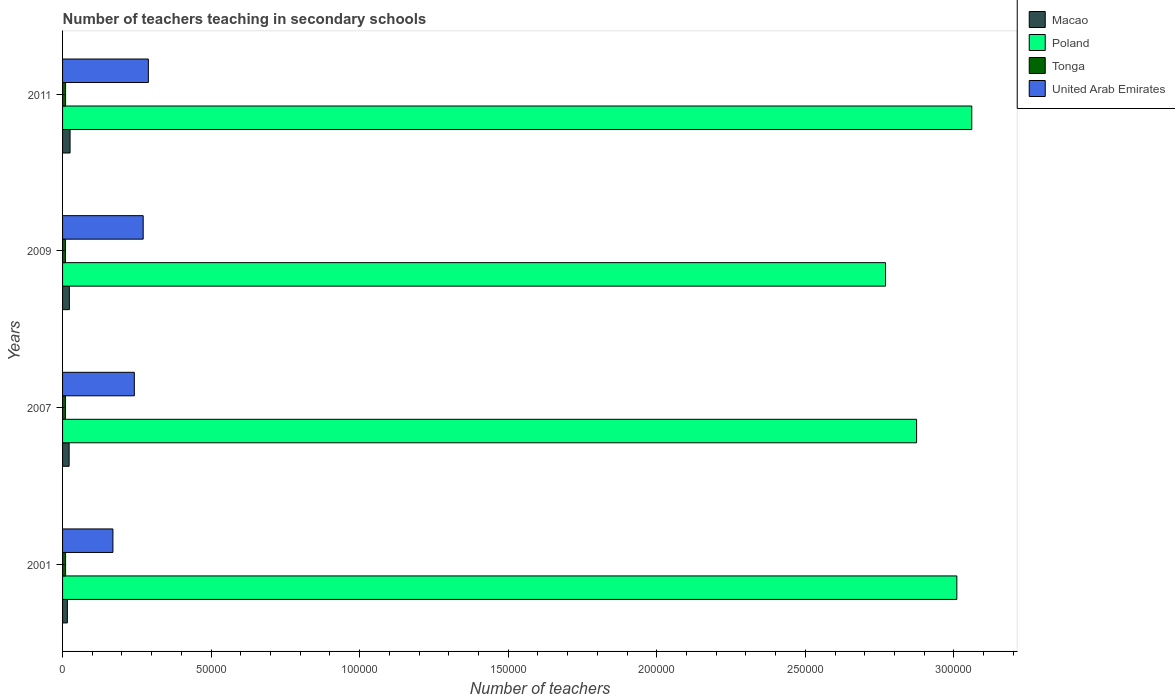How many different coloured bars are there?
Provide a short and direct response. 4. How many groups of bars are there?
Offer a terse response. 4. Are the number of bars per tick equal to the number of legend labels?
Your answer should be compact. Yes. How many bars are there on the 2nd tick from the bottom?
Your answer should be very brief. 4. What is the number of teachers teaching in secondary schools in Poland in 2001?
Offer a terse response. 3.01e+05. Across all years, what is the maximum number of teachers teaching in secondary schools in United Arab Emirates?
Your answer should be very brief. 2.89e+04. Across all years, what is the minimum number of teachers teaching in secondary schools in Macao?
Make the answer very short. 1621. In which year was the number of teachers teaching in secondary schools in United Arab Emirates minimum?
Offer a terse response. 2001. What is the total number of teachers teaching in secondary schools in United Arab Emirates in the graph?
Ensure brevity in your answer.  9.71e+04. What is the difference between the number of teachers teaching in secondary schools in Poland in 2009 and that in 2011?
Offer a terse response. -2.90e+04. What is the difference between the number of teachers teaching in secondary schools in Tonga in 2007 and the number of teachers teaching in secondary schools in Poland in 2001?
Ensure brevity in your answer.  -3.00e+05. What is the average number of teachers teaching in secondary schools in Macao per year?
Your answer should be compact. 2162. In the year 2001, what is the difference between the number of teachers teaching in secondary schools in Macao and number of teachers teaching in secondary schools in Poland?
Provide a succinct answer. -2.99e+05. What is the ratio of the number of teachers teaching in secondary schools in Tonga in 2001 to that in 2009?
Offer a terse response. 1.04. What is the difference between the highest and the second highest number of teachers teaching in secondary schools in Tonga?
Ensure brevity in your answer.  0. What is the difference between the highest and the lowest number of teachers teaching in secondary schools in Poland?
Offer a very short reply. 2.90e+04. Is the sum of the number of teachers teaching in secondary schools in Macao in 2001 and 2009 greater than the maximum number of teachers teaching in secondary schools in Tonga across all years?
Your answer should be compact. Yes. What does the 4th bar from the top in 2009 represents?
Your answer should be compact. Macao. What does the 3rd bar from the bottom in 2011 represents?
Provide a succinct answer. Tonga. Are all the bars in the graph horizontal?
Offer a terse response. Yes. How many years are there in the graph?
Your response must be concise. 4. What is the difference between two consecutive major ticks on the X-axis?
Offer a terse response. 5.00e+04. Are the values on the major ticks of X-axis written in scientific E-notation?
Make the answer very short. No. What is the title of the graph?
Offer a very short reply. Number of teachers teaching in secondary schools. What is the label or title of the X-axis?
Offer a terse response. Number of teachers. What is the Number of teachers of Macao in 2001?
Offer a terse response. 1621. What is the Number of teachers of Poland in 2001?
Ensure brevity in your answer.  3.01e+05. What is the Number of teachers of Tonga in 2001?
Offer a terse response. 1021. What is the Number of teachers of United Arab Emirates in 2001?
Your answer should be very brief. 1.70e+04. What is the Number of teachers in Macao in 2007?
Offer a very short reply. 2210. What is the Number of teachers of Poland in 2007?
Give a very brief answer. 2.87e+05. What is the Number of teachers in Tonga in 2007?
Make the answer very short. 982. What is the Number of teachers of United Arab Emirates in 2007?
Provide a short and direct response. 2.42e+04. What is the Number of teachers in Macao in 2009?
Give a very brief answer. 2294. What is the Number of teachers in Poland in 2009?
Offer a terse response. 2.77e+05. What is the Number of teachers of Tonga in 2009?
Your response must be concise. 981. What is the Number of teachers in United Arab Emirates in 2009?
Provide a succinct answer. 2.71e+04. What is the Number of teachers in Macao in 2011?
Offer a very short reply. 2523. What is the Number of teachers of Poland in 2011?
Keep it short and to the point. 3.06e+05. What is the Number of teachers in Tonga in 2011?
Offer a very short reply. 1021. What is the Number of teachers of United Arab Emirates in 2011?
Your response must be concise. 2.89e+04. Across all years, what is the maximum Number of teachers in Macao?
Your answer should be very brief. 2523. Across all years, what is the maximum Number of teachers in Poland?
Your response must be concise. 3.06e+05. Across all years, what is the maximum Number of teachers in Tonga?
Give a very brief answer. 1021. Across all years, what is the maximum Number of teachers in United Arab Emirates?
Provide a succinct answer. 2.89e+04. Across all years, what is the minimum Number of teachers of Macao?
Offer a very short reply. 1621. Across all years, what is the minimum Number of teachers of Poland?
Keep it short and to the point. 2.77e+05. Across all years, what is the minimum Number of teachers in Tonga?
Ensure brevity in your answer.  981. Across all years, what is the minimum Number of teachers in United Arab Emirates?
Your answer should be very brief. 1.70e+04. What is the total Number of teachers of Macao in the graph?
Your answer should be very brief. 8648. What is the total Number of teachers in Poland in the graph?
Make the answer very short. 1.17e+06. What is the total Number of teachers of Tonga in the graph?
Your response must be concise. 4005. What is the total Number of teachers in United Arab Emirates in the graph?
Your answer should be very brief. 9.71e+04. What is the difference between the Number of teachers of Macao in 2001 and that in 2007?
Offer a very short reply. -589. What is the difference between the Number of teachers of Poland in 2001 and that in 2007?
Provide a short and direct response. 1.35e+04. What is the difference between the Number of teachers in Tonga in 2001 and that in 2007?
Ensure brevity in your answer.  39. What is the difference between the Number of teachers of United Arab Emirates in 2001 and that in 2007?
Your answer should be very brief. -7202. What is the difference between the Number of teachers of Macao in 2001 and that in 2009?
Your answer should be very brief. -673. What is the difference between the Number of teachers in Poland in 2001 and that in 2009?
Make the answer very short. 2.40e+04. What is the difference between the Number of teachers in Tonga in 2001 and that in 2009?
Make the answer very short. 40. What is the difference between the Number of teachers of United Arab Emirates in 2001 and that in 2009?
Provide a succinct answer. -1.02e+04. What is the difference between the Number of teachers in Macao in 2001 and that in 2011?
Keep it short and to the point. -902. What is the difference between the Number of teachers of Poland in 2001 and that in 2011?
Keep it short and to the point. -5020. What is the difference between the Number of teachers in Tonga in 2001 and that in 2011?
Give a very brief answer. 0. What is the difference between the Number of teachers in United Arab Emirates in 2001 and that in 2011?
Your answer should be very brief. -1.19e+04. What is the difference between the Number of teachers of Macao in 2007 and that in 2009?
Provide a succinct answer. -84. What is the difference between the Number of teachers in Poland in 2007 and that in 2009?
Your answer should be very brief. 1.05e+04. What is the difference between the Number of teachers in Tonga in 2007 and that in 2009?
Your response must be concise. 1. What is the difference between the Number of teachers in United Arab Emirates in 2007 and that in 2009?
Give a very brief answer. -2983. What is the difference between the Number of teachers of Macao in 2007 and that in 2011?
Ensure brevity in your answer.  -313. What is the difference between the Number of teachers in Poland in 2007 and that in 2011?
Your answer should be very brief. -1.86e+04. What is the difference between the Number of teachers of Tonga in 2007 and that in 2011?
Provide a succinct answer. -39. What is the difference between the Number of teachers of United Arab Emirates in 2007 and that in 2011?
Make the answer very short. -4722. What is the difference between the Number of teachers in Macao in 2009 and that in 2011?
Keep it short and to the point. -229. What is the difference between the Number of teachers in Poland in 2009 and that in 2011?
Your answer should be compact. -2.90e+04. What is the difference between the Number of teachers of United Arab Emirates in 2009 and that in 2011?
Your answer should be very brief. -1739. What is the difference between the Number of teachers in Macao in 2001 and the Number of teachers in Poland in 2007?
Make the answer very short. -2.86e+05. What is the difference between the Number of teachers in Macao in 2001 and the Number of teachers in Tonga in 2007?
Ensure brevity in your answer.  639. What is the difference between the Number of teachers in Macao in 2001 and the Number of teachers in United Arab Emirates in 2007?
Provide a short and direct response. -2.25e+04. What is the difference between the Number of teachers in Poland in 2001 and the Number of teachers in Tonga in 2007?
Give a very brief answer. 3.00e+05. What is the difference between the Number of teachers in Poland in 2001 and the Number of teachers in United Arab Emirates in 2007?
Ensure brevity in your answer.  2.77e+05. What is the difference between the Number of teachers of Tonga in 2001 and the Number of teachers of United Arab Emirates in 2007?
Your answer should be very brief. -2.31e+04. What is the difference between the Number of teachers in Macao in 2001 and the Number of teachers in Poland in 2009?
Make the answer very short. -2.75e+05. What is the difference between the Number of teachers of Macao in 2001 and the Number of teachers of Tonga in 2009?
Your response must be concise. 640. What is the difference between the Number of teachers of Macao in 2001 and the Number of teachers of United Arab Emirates in 2009?
Provide a short and direct response. -2.55e+04. What is the difference between the Number of teachers of Poland in 2001 and the Number of teachers of Tonga in 2009?
Keep it short and to the point. 3.00e+05. What is the difference between the Number of teachers of Poland in 2001 and the Number of teachers of United Arab Emirates in 2009?
Ensure brevity in your answer.  2.74e+05. What is the difference between the Number of teachers of Tonga in 2001 and the Number of teachers of United Arab Emirates in 2009?
Provide a short and direct response. -2.61e+04. What is the difference between the Number of teachers of Macao in 2001 and the Number of teachers of Poland in 2011?
Ensure brevity in your answer.  -3.04e+05. What is the difference between the Number of teachers in Macao in 2001 and the Number of teachers in Tonga in 2011?
Make the answer very short. 600. What is the difference between the Number of teachers in Macao in 2001 and the Number of teachers in United Arab Emirates in 2011?
Offer a very short reply. -2.73e+04. What is the difference between the Number of teachers in Poland in 2001 and the Number of teachers in Tonga in 2011?
Your answer should be very brief. 3.00e+05. What is the difference between the Number of teachers in Poland in 2001 and the Number of teachers in United Arab Emirates in 2011?
Your response must be concise. 2.72e+05. What is the difference between the Number of teachers in Tonga in 2001 and the Number of teachers in United Arab Emirates in 2011?
Offer a terse response. -2.79e+04. What is the difference between the Number of teachers in Macao in 2007 and the Number of teachers in Poland in 2009?
Provide a short and direct response. -2.75e+05. What is the difference between the Number of teachers in Macao in 2007 and the Number of teachers in Tonga in 2009?
Your answer should be very brief. 1229. What is the difference between the Number of teachers in Macao in 2007 and the Number of teachers in United Arab Emirates in 2009?
Offer a very short reply. -2.49e+04. What is the difference between the Number of teachers of Poland in 2007 and the Number of teachers of Tonga in 2009?
Make the answer very short. 2.86e+05. What is the difference between the Number of teachers of Poland in 2007 and the Number of teachers of United Arab Emirates in 2009?
Your answer should be very brief. 2.60e+05. What is the difference between the Number of teachers in Tonga in 2007 and the Number of teachers in United Arab Emirates in 2009?
Give a very brief answer. -2.62e+04. What is the difference between the Number of teachers in Macao in 2007 and the Number of teachers in Poland in 2011?
Your answer should be very brief. -3.04e+05. What is the difference between the Number of teachers in Macao in 2007 and the Number of teachers in Tonga in 2011?
Offer a very short reply. 1189. What is the difference between the Number of teachers in Macao in 2007 and the Number of teachers in United Arab Emirates in 2011?
Ensure brevity in your answer.  -2.67e+04. What is the difference between the Number of teachers of Poland in 2007 and the Number of teachers of Tonga in 2011?
Give a very brief answer. 2.86e+05. What is the difference between the Number of teachers in Poland in 2007 and the Number of teachers in United Arab Emirates in 2011?
Ensure brevity in your answer.  2.59e+05. What is the difference between the Number of teachers in Tonga in 2007 and the Number of teachers in United Arab Emirates in 2011?
Ensure brevity in your answer.  -2.79e+04. What is the difference between the Number of teachers in Macao in 2009 and the Number of teachers in Poland in 2011?
Give a very brief answer. -3.04e+05. What is the difference between the Number of teachers of Macao in 2009 and the Number of teachers of Tonga in 2011?
Your answer should be very brief. 1273. What is the difference between the Number of teachers of Macao in 2009 and the Number of teachers of United Arab Emirates in 2011?
Give a very brief answer. -2.66e+04. What is the difference between the Number of teachers of Poland in 2009 and the Number of teachers of Tonga in 2011?
Your answer should be compact. 2.76e+05. What is the difference between the Number of teachers of Poland in 2009 and the Number of teachers of United Arab Emirates in 2011?
Offer a very short reply. 2.48e+05. What is the difference between the Number of teachers in Tonga in 2009 and the Number of teachers in United Arab Emirates in 2011?
Give a very brief answer. -2.79e+04. What is the average Number of teachers in Macao per year?
Your answer should be very brief. 2162. What is the average Number of teachers in Poland per year?
Keep it short and to the point. 2.93e+05. What is the average Number of teachers of Tonga per year?
Offer a terse response. 1001.25. What is the average Number of teachers of United Arab Emirates per year?
Keep it short and to the point. 2.43e+04. In the year 2001, what is the difference between the Number of teachers in Macao and Number of teachers in Poland?
Your answer should be compact. -2.99e+05. In the year 2001, what is the difference between the Number of teachers of Macao and Number of teachers of Tonga?
Keep it short and to the point. 600. In the year 2001, what is the difference between the Number of teachers in Macao and Number of teachers in United Arab Emirates?
Offer a very short reply. -1.53e+04. In the year 2001, what is the difference between the Number of teachers of Poland and Number of teachers of Tonga?
Your response must be concise. 3.00e+05. In the year 2001, what is the difference between the Number of teachers of Poland and Number of teachers of United Arab Emirates?
Your response must be concise. 2.84e+05. In the year 2001, what is the difference between the Number of teachers in Tonga and Number of teachers in United Arab Emirates?
Offer a very short reply. -1.59e+04. In the year 2007, what is the difference between the Number of teachers of Macao and Number of teachers of Poland?
Your answer should be compact. -2.85e+05. In the year 2007, what is the difference between the Number of teachers in Macao and Number of teachers in Tonga?
Provide a short and direct response. 1228. In the year 2007, what is the difference between the Number of teachers in Macao and Number of teachers in United Arab Emirates?
Your answer should be compact. -2.19e+04. In the year 2007, what is the difference between the Number of teachers of Poland and Number of teachers of Tonga?
Provide a succinct answer. 2.86e+05. In the year 2007, what is the difference between the Number of teachers in Poland and Number of teachers in United Arab Emirates?
Your response must be concise. 2.63e+05. In the year 2007, what is the difference between the Number of teachers of Tonga and Number of teachers of United Arab Emirates?
Keep it short and to the point. -2.32e+04. In the year 2009, what is the difference between the Number of teachers in Macao and Number of teachers in Poland?
Your answer should be compact. -2.75e+05. In the year 2009, what is the difference between the Number of teachers in Macao and Number of teachers in Tonga?
Your response must be concise. 1313. In the year 2009, what is the difference between the Number of teachers of Macao and Number of teachers of United Arab Emirates?
Offer a terse response. -2.48e+04. In the year 2009, what is the difference between the Number of teachers in Poland and Number of teachers in Tonga?
Make the answer very short. 2.76e+05. In the year 2009, what is the difference between the Number of teachers in Poland and Number of teachers in United Arab Emirates?
Ensure brevity in your answer.  2.50e+05. In the year 2009, what is the difference between the Number of teachers of Tonga and Number of teachers of United Arab Emirates?
Your answer should be very brief. -2.62e+04. In the year 2011, what is the difference between the Number of teachers of Macao and Number of teachers of Poland?
Make the answer very short. -3.03e+05. In the year 2011, what is the difference between the Number of teachers of Macao and Number of teachers of Tonga?
Give a very brief answer. 1502. In the year 2011, what is the difference between the Number of teachers of Macao and Number of teachers of United Arab Emirates?
Offer a terse response. -2.64e+04. In the year 2011, what is the difference between the Number of teachers of Poland and Number of teachers of Tonga?
Your answer should be very brief. 3.05e+05. In the year 2011, what is the difference between the Number of teachers of Poland and Number of teachers of United Arab Emirates?
Keep it short and to the point. 2.77e+05. In the year 2011, what is the difference between the Number of teachers of Tonga and Number of teachers of United Arab Emirates?
Offer a terse response. -2.79e+04. What is the ratio of the Number of teachers of Macao in 2001 to that in 2007?
Give a very brief answer. 0.73. What is the ratio of the Number of teachers in Poland in 2001 to that in 2007?
Keep it short and to the point. 1.05. What is the ratio of the Number of teachers in Tonga in 2001 to that in 2007?
Offer a terse response. 1.04. What is the ratio of the Number of teachers in United Arab Emirates in 2001 to that in 2007?
Provide a short and direct response. 0.7. What is the ratio of the Number of teachers of Macao in 2001 to that in 2009?
Offer a very short reply. 0.71. What is the ratio of the Number of teachers of Poland in 2001 to that in 2009?
Your response must be concise. 1.09. What is the ratio of the Number of teachers in Tonga in 2001 to that in 2009?
Give a very brief answer. 1.04. What is the ratio of the Number of teachers of United Arab Emirates in 2001 to that in 2009?
Provide a short and direct response. 0.62. What is the ratio of the Number of teachers of Macao in 2001 to that in 2011?
Give a very brief answer. 0.64. What is the ratio of the Number of teachers in Poland in 2001 to that in 2011?
Offer a terse response. 0.98. What is the ratio of the Number of teachers of Tonga in 2001 to that in 2011?
Offer a terse response. 1. What is the ratio of the Number of teachers in United Arab Emirates in 2001 to that in 2011?
Keep it short and to the point. 0.59. What is the ratio of the Number of teachers of Macao in 2007 to that in 2009?
Give a very brief answer. 0.96. What is the ratio of the Number of teachers in Poland in 2007 to that in 2009?
Offer a very short reply. 1.04. What is the ratio of the Number of teachers in United Arab Emirates in 2007 to that in 2009?
Your answer should be compact. 0.89. What is the ratio of the Number of teachers in Macao in 2007 to that in 2011?
Offer a terse response. 0.88. What is the ratio of the Number of teachers of Poland in 2007 to that in 2011?
Provide a succinct answer. 0.94. What is the ratio of the Number of teachers in Tonga in 2007 to that in 2011?
Offer a terse response. 0.96. What is the ratio of the Number of teachers of United Arab Emirates in 2007 to that in 2011?
Offer a terse response. 0.84. What is the ratio of the Number of teachers of Macao in 2009 to that in 2011?
Offer a terse response. 0.91. What is the ratio of the Number of teachers in Poland in 2009 to that in 2011?
Your response must be concise. 0.91. What is the ratio of the Number of teachers of Tonga in 2009 to that in 2011?
Offer a very short reply. 0.96. What is the ratio of the Number of teachers in United Arab Emirates in 2009 to that in 2011?
Your answer should be very brief. 0.94. What is the difference between the highest and the second highest Number of teachers in Macao?
Your answer should be very brief. 229. What is the difference between the highest and the second highest Number of teachers of Poland?
Your answer should be compact. 5020. What is the difference between the highest and the second highest Number of teachers of United Arab Emirates?
Your answer should be compact. 1739. What is the difference between the highest and the lowest Number of teachers in Macao?
Ensure brevity in your answer.  902. What is the difference between the highest and the lowest Number of teachers in Poland?
Give a very brief answer. 2.90e+04. What is the difference between the highest and the lowest Number of teachers of United Arab Emirates?
Offer a terse response. 1.19e+04. 